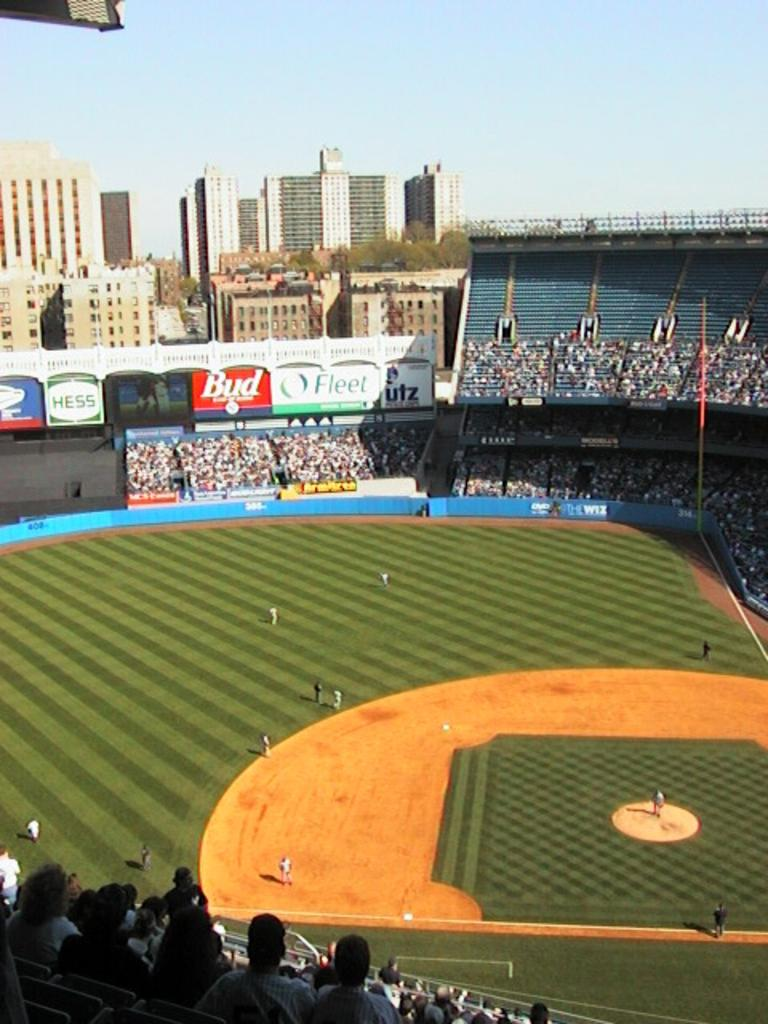<image>
Create a compact narrative representing the image presented. A baseball field stadium is filled with people and the stadium has the ads Bud and Fleet beside each other 